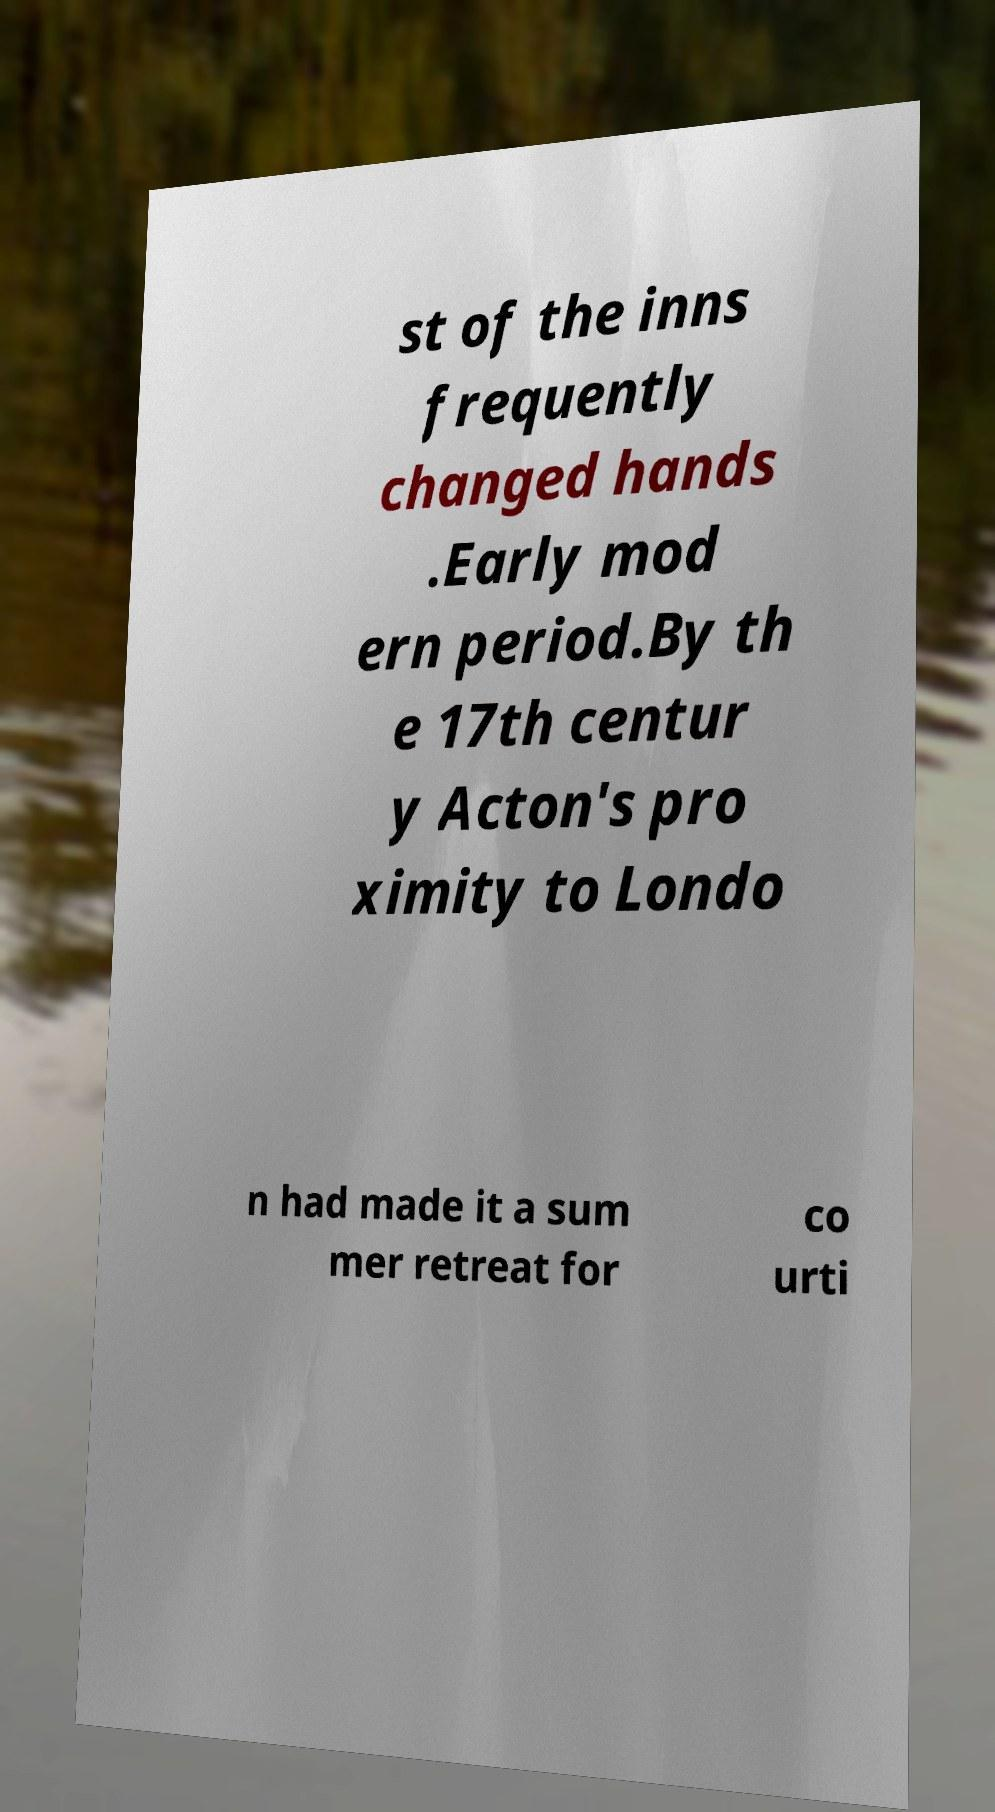I need the written content from this picture converted into text. Can you do that? st of the inns frequently changed hands .Early mod ern period.By th e 17th centur y Acton's pro ximity to Londo n had made it a sum mer retreat for co urti 